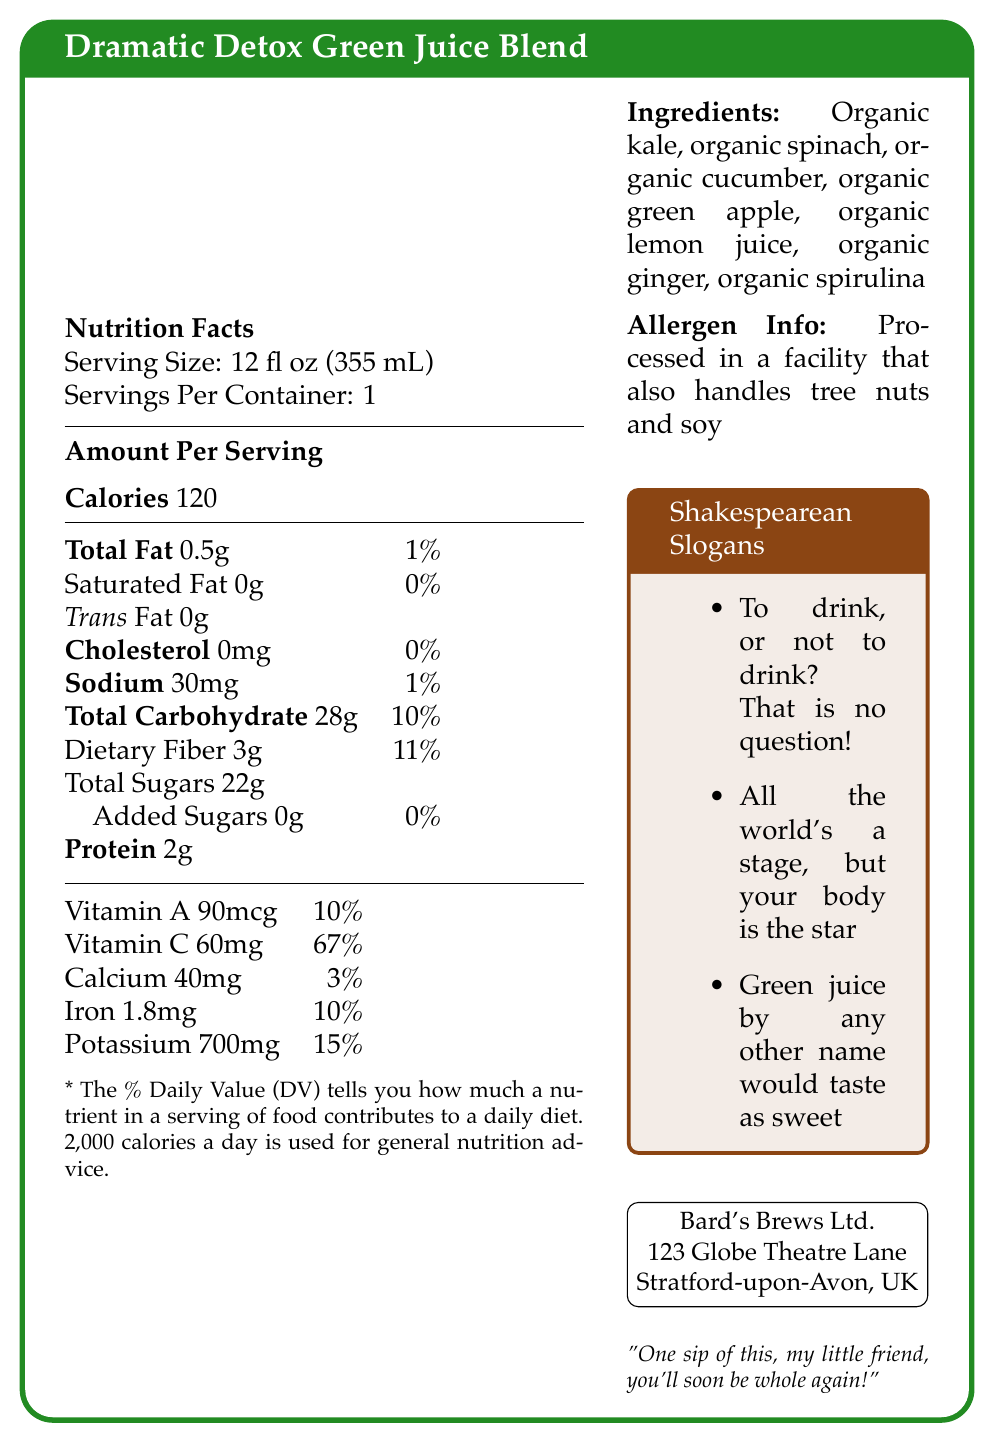what is the serving size of the Dramatic Detox Green Juice Blend? The serving size is clearly mentioned under the "Nutrition Facts" section.
Answer: 12 fl oz (355 mL) how many calories are in one serving of the juice blend? The calories per serving are stated under the "Amount Per Serving" section.
Answer: 120 what percentage of daily value of Vitamin C does one serving provide? The daily value percentage of Vitamin C is listed under the vitamin and mineral content.
Answer: 67% which type of fat has the highest amount in this juice blend? The label lists Total Fat as 0.5g, while Saturated Fat and Trans Fat have 0g each.
Answer: Total Fat what is the amount of protein in one serving? The amount of protein is stated under the "Amount Per Serving" section.
Answer: 2g what are the main ingredients of the juice blend? The ingredients are listed in the "Ingredients" section.
Answer: Organic kale, organic spinach, organic cucumber, organic green apple, organic lemon juice, organic ginger, organic spirulina which of the following vitamins or minerals has the highest daily value percentage in one serving? A. Vitamin A B. Vitamin C C. Calcium D. Iron Vitamin C has the highest daily value percentage at 67%.
Answer: B. Vitamin C what is the total carbohydrate content in one serving? A. 28g B. 3g C. 22g D. 0g The total carbohydrate content is listed as 28g under the "Amount Per Serving" section.
Answer: A. 28g does the juice blend contain added sugars? The "Added Sugars" amount is listed as 0g in the nutrition facts.
Answer: No is the product suitable for someone allergic to tree nuts? The allergen information specifies that the product is processed in a facility that handles tree nuts.
Answer: No summarize the main points of the document. This summary covers the key nutritional values, ingredients, manufacturer information, and unique aspects like the Shakespearean slogans.
Answer: The Dramatic Detox Green Juice Blend is a nutritional juice with 120 calories per serving, containing various organic ingredients like kale, spinach, and cucumber. It provides significant amounts of Vitamin C and Potassium. The product is made by Bard's Brews Ltd. and includes fun Shakespearean slogans. what are the nutritional benefits of this juice blend? The document does not provide detailed explanations on the nutritional benefits other than listing the nutrition facts.
Answer: Not enough information where is Bard's Brews Ltd. located? The manufacturer's address is clearly stated in the document.
Answer: 123 Globe Theatre Lane, Stratford-upon-Avon, UK is there any cholesterol in the juice blend? The nutrition facts section mentions that the cholesterol amount is 0mg.
Answer: No how many servings are there per container? The number of servings per container is listed in the "Nutrition Facts" section.
Answer: 1 which slogan is included in the document? A. "The juice of life!" B. "Energize your day!" C. "To drink, or not to drink? That is no question!" This slogan is one of the Shakespearean-inspired slogans included in the document.
Answer: C. "To drink, or not to drink? That is no question!" does the juice blend contain iron? The nutrition facts section lists iron content as 1.8mg, which is 10% of the daily value.
Answer: Yes 